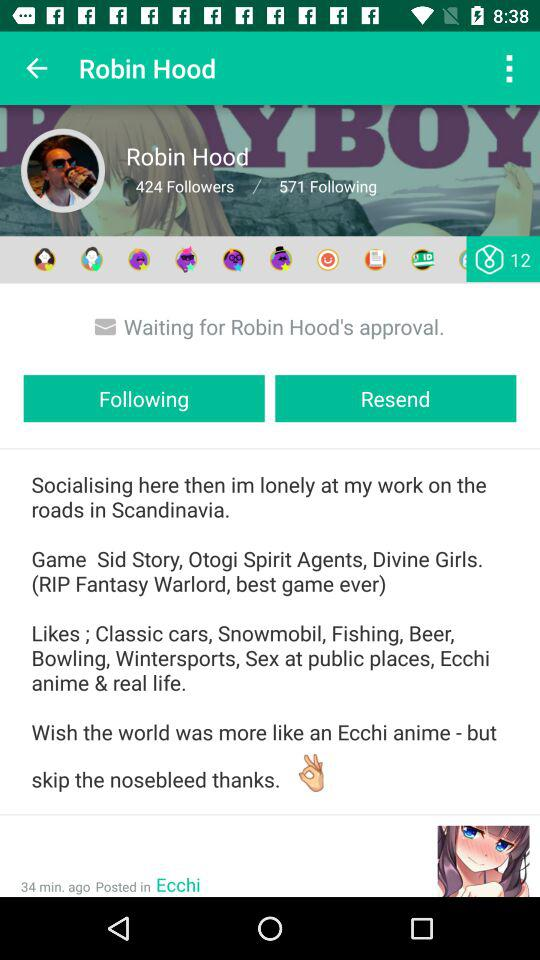When was the post posted? The post was posted 34 minutes ago. 